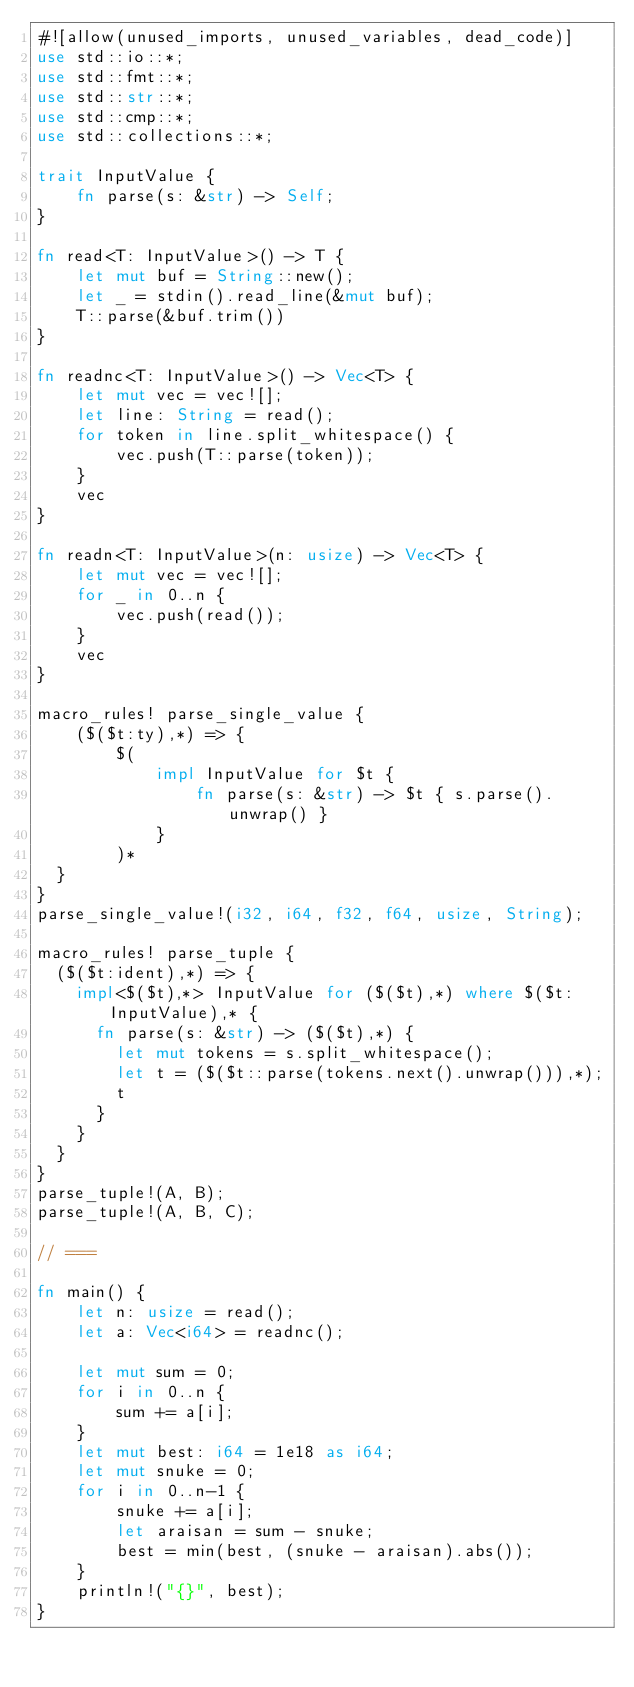Convert code to text. <code><loc_0><loc_0><loc_500><loc_500><_Rust_>#![allow(unused_imports, unused_variables, dead_code)]
use std::io::*;
use std::fmt::*;
use std::str::*;
use std::cmp::*;
use std::collections::*;

trait InputValue {
    fn parse(s: &str) -> Self;
}

fn read<T: InputValue>() -> T {
    let mut buf = String::new();
    let _ = stdin().read_line(&mut buf);
    T::parse(&buf.trim())
}

fn readnc<T: InputValue>() -> Vec<T> {
    let mut vec = vec![];
    let line: String = read();
    for token in line.split_whitespace() {
        vec.push(T::parse(token));
    }
    vec
}

fn readn<T: InputValue>(n: usize) -> Vec<T> {
    let mut vec = vec![];
    for _ in 0..n {
        vec.push(read());
    }
    vec
}

macro_rules! parse_single_value {
    ($($t:ty),*) => {
        $(
            impl InputValue for $t {
                fn parse(s: &str) -> $t { s.parse().unwrap() }
            }
        )*
	}
}
parse_single_value!(i32, i64, f32, f64, usize, String);

macro_rules! parse_tuple {
	($($t:ident),*) => {
		impl<$($t),*> InputValue for ($($t),*) where $($t: InputValue),* {
			fn parse(s: &str) -> ($($t),*) {
				let mut tokens = s.split_whitespace();
				let t = ($($t::parse(tokens.next().unwrap())),*);
				t
			}
		}
	}
}
parse_tuple!(A, B);
parse_tuple!(A, B, C);

// ===

fn main() {
    let n: usize = read();
    let a: Vec<i64> = readnc();

    let mut sum = 0;
    for i in 0..n {
        sum += a[i];
    }
    let mut best: i64 = 1e18 as i64;
    let mut snuke = 0;
    for i in 0..n-1 {
        snuke += a[i];
        let araisan = sum - snuke;
        best = min(best, (snuke - araisan).abs());
    }
    println!("{}", best);
}</code> 